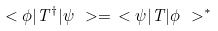Convert formula to latex. <formula><loc_0><loc_0><loc_500><loc_500>\ < \phi | T ^ { \dag } | \psi \ > = \ < \psi | T | \phi \ > ^ { * }</formula> 